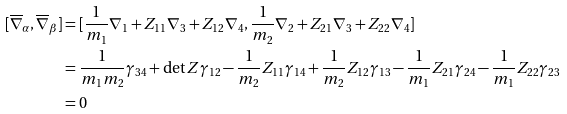Convert formula to latex. <formula><loc_0><loc_0><loc_500><loc_500>[ \overline { \nabla } _ { \alpha } , \overline { \nabla } _ { \beta } ] & = [ \frac { 1 } { m _ { 1 } } \nabla _ { 1 } + Z _ { 1 1 } \nabla _ { 3 } + Z _ { 1 2 } \nabla _ { 4 } , \frac { 1 } { m _ { 2 } } \nabla _ { 2 } + Z _ { 2 1 } \nabla _ { 3 } + Z _ { 2 2 } \nabla _ { 4 } ] \\ & = \frac { 1 } { m _ { 1 } m _ { 2 } } \gamma _ { 3 4 } + \det Z \gamma _ { 1 2 } - \frac { 1 } { m _ { 2 } } Z _ { 1 1 } \gamma _ { 1 4 } + \frac { 1 } { m _ { 2 } } Z _ { 1 2 } \gamma _ { 1 3 } - \frac { 1 } { m _ { 1 } } Z _ { 2 1 } \gamma _ { 2 4 } - \frac { 1 } { m _ { 1 } } Z _ { 2 2 } \gamma _ { 2 3 } \\ & = 0</formula> 